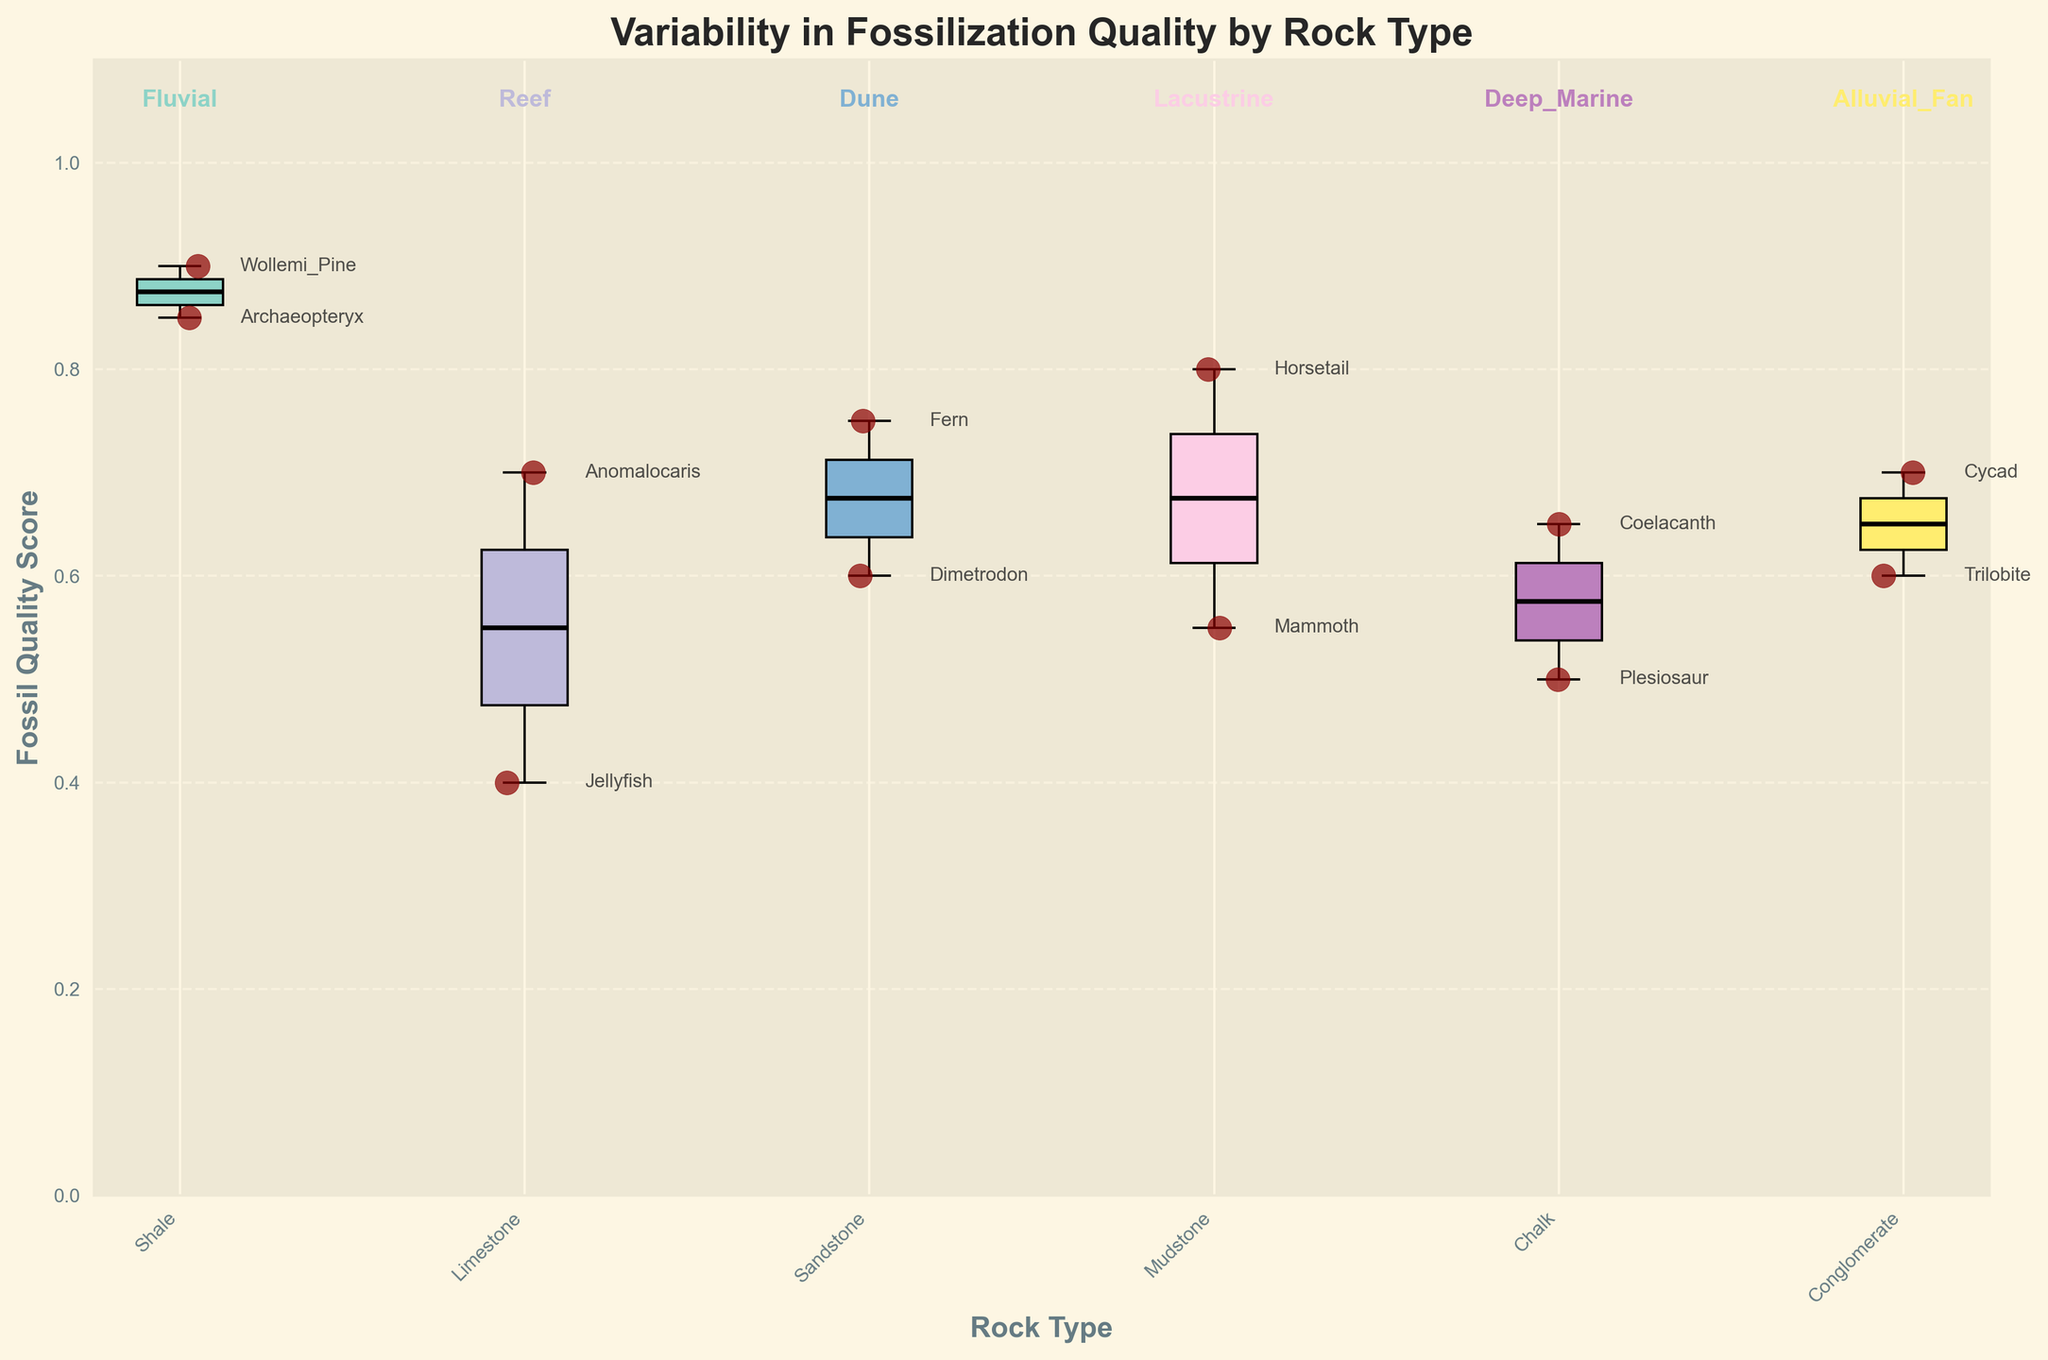What is the title of the figure? The title is usually found at the top of the figure. In this case, it reads 'Variability in Fossilization Quality by Rock Type'.
Answer: Variability in Fossilization Quality by Rock Type Which rock type has the highest median Fossil Quality Score? Look for the box plot with the median line (black line) highest on the Y-axis. In this case, 'Shale' has the highest median Fossil Quality Score.
Answer: Shale How many species are represented in Sandstone rock type? Identify the box plot corresponding to 'Sandstone' and count the number of scatter points around it. There are two species represented.
Answer: 2 Which sediment deposition environment is associated with the rock type having the widest box plot? The widest box plot corresponds to the 'Fluvial' environment, labeled above the 'Shale' rock type.
Answer: Fluvial Which species found in Limestone rock type has the higher Fossil Quality Score, Jellyfish or Anomalocaris? Within the 'Limestone' box plot, compare the scatter points labeled ‘Jellyfish’ and ‘Anomalocaris’. 'Anomalocaris' has a higher score.
Answer: Anomalocaris What is the range of Fossil Quality Scores for the rock type with the lowest median? The rock type 'Chalk' has the lowest median. The range is from the lower whisker to the upper whisker of the box plot.
Answer: 0.5 to 0.65 What is the average Fossil Quality Score for species in Mudstone rock type? Sum the Fossil Quality Scores for 'Horsetail' and 'Mammoth' (0.8 + 0.55) and divide by the number of species (2). The average score is 0.675.
Answer: 0.675 Between Conglomerate and Chalk, which rock type has better fossilization quality and why? Compare the box plots of 'Conglomerate' and 'Chalk'. 'Conglomerate' has a higher median score and less variability, which suggests better fossil quality.
Answer: Conglomerate What is the Fossil Quality Score of the Coelacanth species? Locate the labeled scatter point for 'Coelacanth' within the 'Chalk' rock type. The score is shown near the scatter point.
Answer: 0.65 